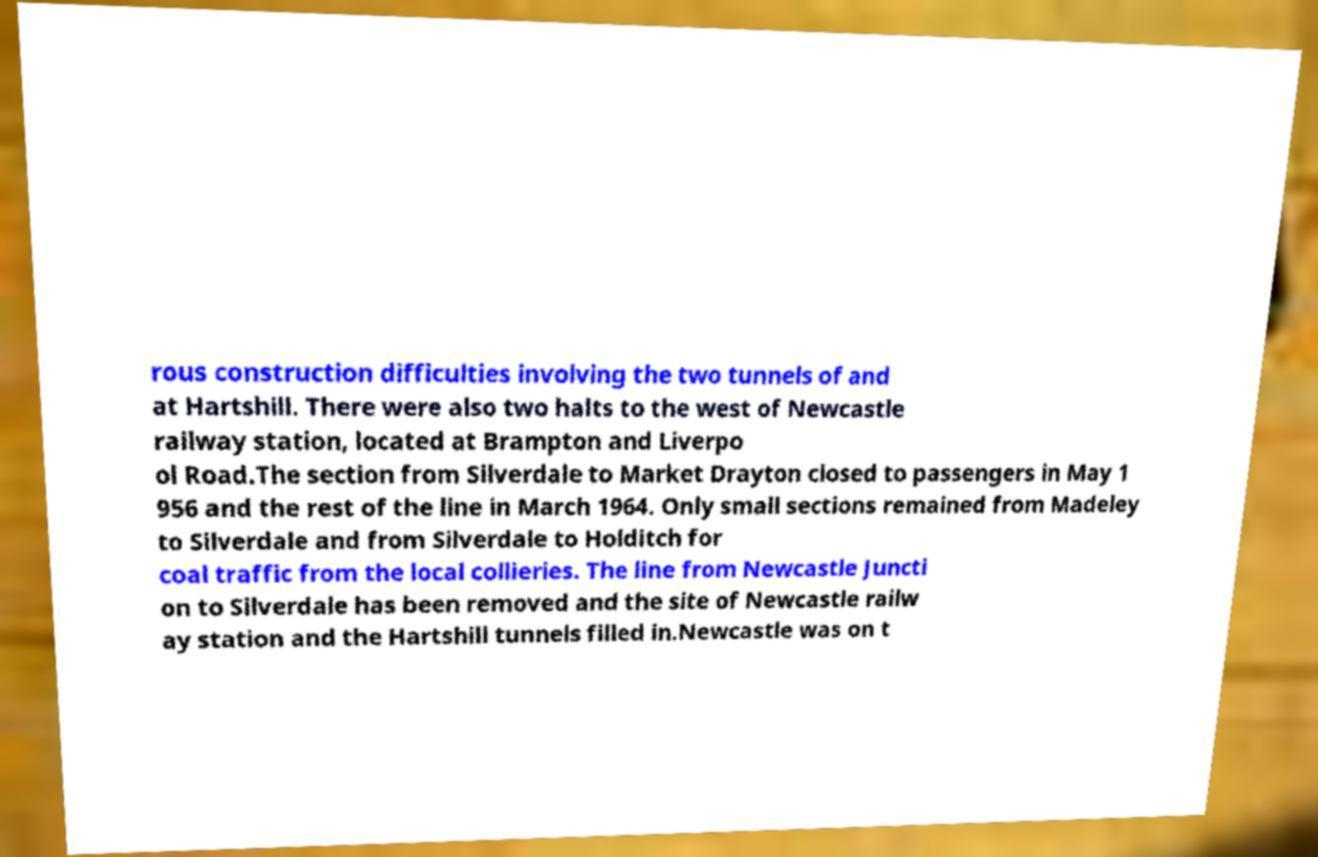Could you assist in decoding the text presented in this image and type it out clearly? rous construction difficulties involving the two tunnels of and at Hartshill. There were also two halts to the west of Newcastle railway station, located at Brampton and Liverpo ol Road.The section from Silverdale to Market Drayton closed to passengers in May 1 956 and the rest of the line in March 1964. Only small sections remained from Madeley to Silverdale and from Silverdale to Holditch for coal traffic from the local collieries. The line from Newcastle Juncti on to Silverdale has been removed and the site of Newcastle railw ay station and the Hartshill tunnels filled in.Newcastle was on t 